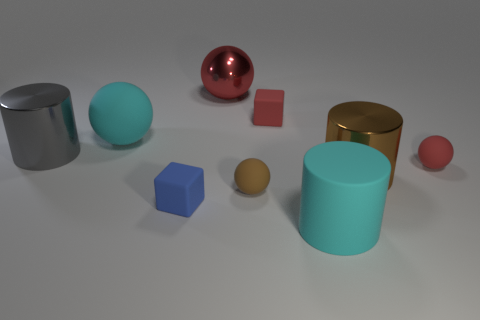Add 1 large cyan things. How many objects exist? 10 Subtract all cylinders. How many objects are left? 6 Add 8 blue cubes. How many blue cubes are left? 9 Add 1 big cyan cylinders. How many big cyan cylinders exist? 2 Subtract 0 gray cubes. How many objects are left? 9 Subtract all brown balls. Subtract all gray metallic cylinders. How many objects are left? 7 